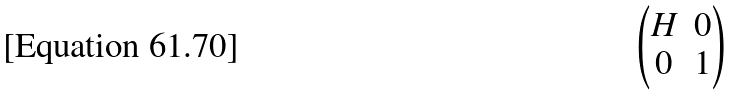Convert formula to latex. <formula><loc_0><loc_0><loc_500><loc_500>\begin{pmatrix} H & 0 \\ 0 & 1 \end{pmatrix}</formula> 